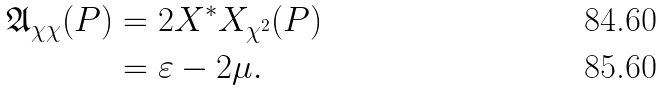<formula> <loc_0><loc_0><loc_500><loc_500>\mathfrak { A } _ { \chi \chi } ( P ) & = 2 X ^ { \ast } X _ { \chi ^ { 2 } } ( P ) \\ & = \varepsilon - 2 \mu .</formula> 